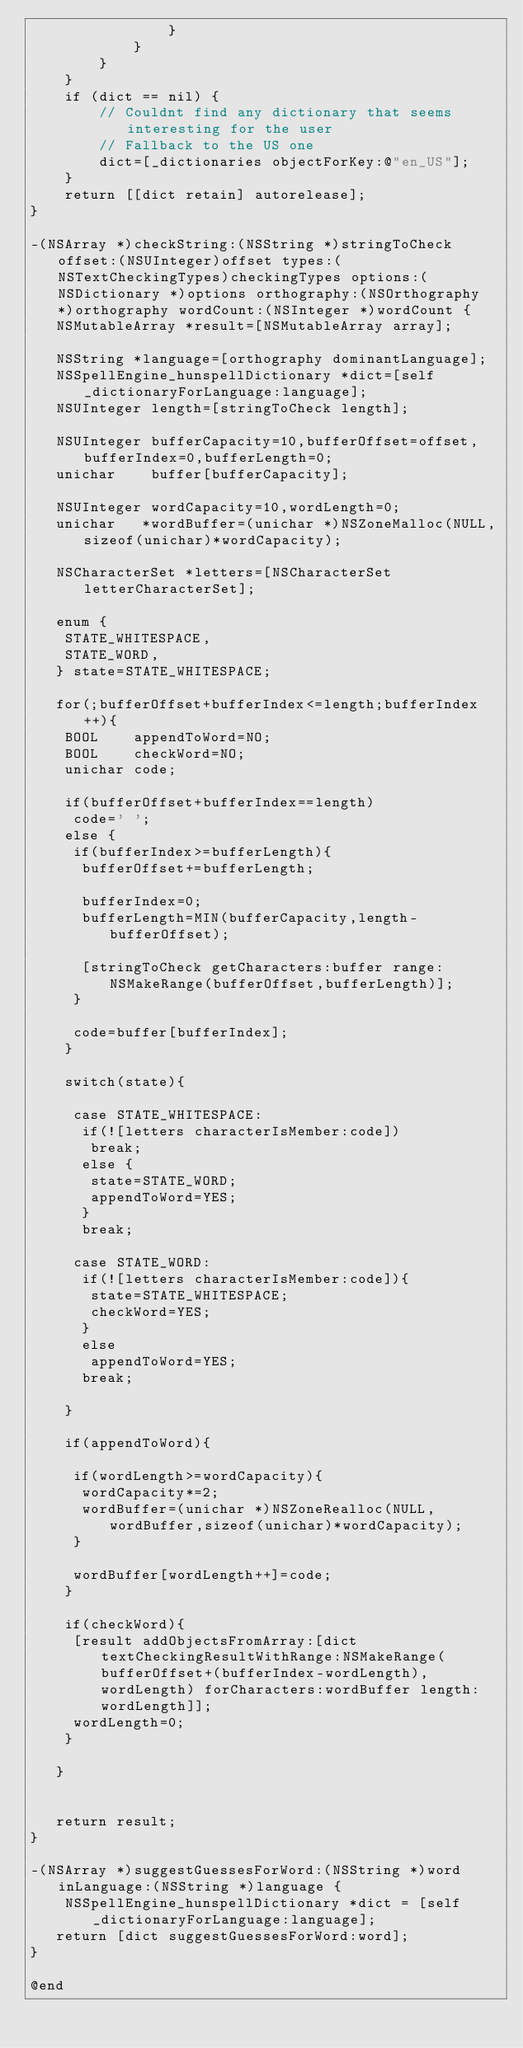Convert code to text. <code><loc_0><loc_0><loc_500><loc_500><_ObjectiveC_>				}
			}
		}
	}
	if (dict == nil) {
		// Couldnt find any dictionary that seems interesting for the user
		// Fallback to the US one
		dict=[_dictionaries objectForKey:@"en_US"];
	}	
	return [[dict retain] autorelease];
}

-(NSArray *)checkString:(NSString *)stringToCheck offset:(NSUInteger)offset types:(NSTextCheckingTypes)checkingTypes options:(NSDictionary *)options orthography:(NSOrthography *)orthography wordCount:(NSInteger *)wordCount {
   NSMutableArray *result=[NSMutableArray array];
   
   NSString *language=[orthography dominantLanguage];
   NSSpellEngine_hunspellDictionary *dict=[self _dictionaryForLanguage:language];
   NSUInteger length=[stringToCheck length];
   
   NSUInteger bufferCapacity=10,bufferOffset=offset,bufferIndex=0,bufferLength=0;
   unichar    buffer[bufferCapacity];
   
   NSUInteger wordCapacity=10,wordLength=0;
   unichar   *wordBuffer=(unichar *)NSZoneMalloc(NULL,sizeof(unichar)*wordCapacity);
   
   NSCharacterSet *letters=[NSCharacterSet letterCharacterSet];
   
   enum {
    STATE_WHITESPACE,
    STATE_WORD,
   } state=STATE_WHITESPACE;
   
   for(;bufferOffset+bufferIndex<=length;bufferIndex++){
    BOOL    appendToWord=NO;
    BOOL    checkWord=NO;
    unichar code;
        
    if(bufferOffset+bufferIndex==length)
     code=' ';
    else {
     if(bufferIndex>=bufferLength){
      bufferOffset+=bufferLength;
     
      bufferIndex=0;
      bufferLength=MIN(bufferCapacity,length-bufferOffset);
     
      [stringToCheck getCharacters:buffer range:NSMakeRange(bufferOffset,bufferLength)];
     }
    
     code=buffer[bufferIndex];
    }
    
    switch(state){
    
     case STATE_WHITESPACE:
      if(![letters characterIsMember:code])
       break;
      else {
       state=STATE_WORD;
       appendToWord=YES;
      }
      break;
    
     case STATE_WORD:
      if(![letters characterIsMember:code]){
       state=STATE_WHITESPACE;
       checkWord=YES;
      }
      else
       appendToWord=YES;
      break;
      
    }
    
    if(appendToWord){
    
     if(wordLength>=wordCapacity){
      wordCapacity*=2;
      wordBuffer=(unichar *)NSZoneRealloc(NULL,wordBuffer,sizeof(unichar)*wordCapacity);
     }
     
     wordBuffer[wordLength++]=code;
    }
    
    if(checkWord){
     [result addObjectsFromArray:[dict textCheckingResultWithRange:NSMakeRange(bufferOffset+(bufferIndex-wordLength),wordLength) forCharacters:wordBuffer length:wordLength]];
     wordLength=0;
    }
    
   }
   
   
   return result;
}

-(NSArray *)suggestGuessesForWord:(NSString *)word inLanguage:(NSString *)language {
	NSSpellEngine_hunspellDictionary *dict = [self _dictionaryForLanguage:language];
   return [dict suggestGuessesForWord:word];    
}

@end
</code> 